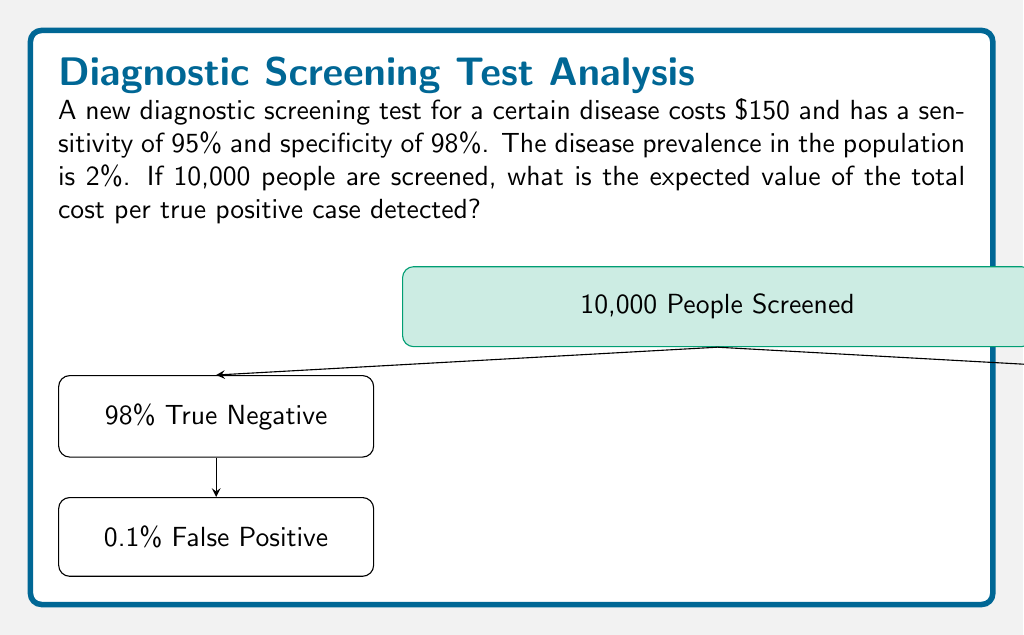Provide a solution to this math problem. Let's break this down step-by-step:

1) First, we need to calculate the number of true positive cases:
   * Population screened = 10,000
   * Disease prevalence = 2% = 0.02
   * True positives = 10,000 * 0.02 * 0.95 (sensitivity) = 190

2) Now, let's calculate the total cost of screening:
   * Cost per test = $150
   * Total cost = 10,000 * $150 = $1,500,000

3) To find the cost per true positive case, we divide the total cost by the number of true positives:
   
   $$ \text{Cost per true positive} = \frac{\text{Total cost}}{\text{Number of true positives}} = \frac{1,500,000}{190} = \$7,894.74 $$

Therefore, the expected value of the total cost per true positive case detected is $7,894.74.
Answer: $7,894.74 